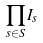Convert formula to latex. <formula><loc_0><loc_0><loc_500><loc_500>\prod _ { s \in S } I _ { s }</formula> 